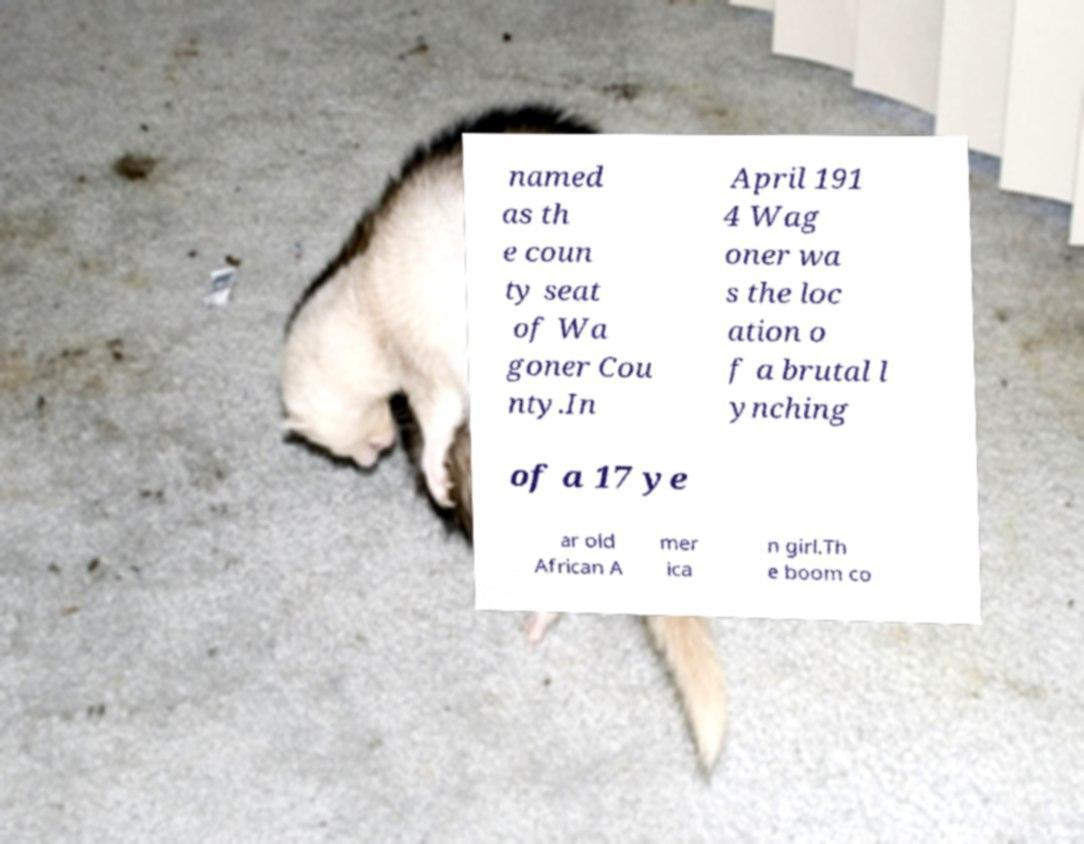Can you read and provide the text displayed in the image?This photo seems to have some interesting text. Can you extract and type it out for me? named as th e coun ty seat of Wa goner Cou nty.In April 191 4 Wag oner wa s the loc ation o f a brutal l ynching of a 17 ye ar old African A mer ica n girl.Th e boom co 